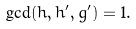Convert formula to latex. <formula><loc_0><loc_0><loc_500><loc_500>\gcd ( \bar { h } , \bar { h } ^ { \prime } , \bar { g } ^ { \prime } ) = 1 .</formula> 